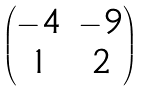Convert formula to latex. <formula><loc_0><loc_0><loc_500><loc_500>\begin{pmatrix} - 4 & - 9 \\ 1 & 2 \end{pmatrix}</formula> 